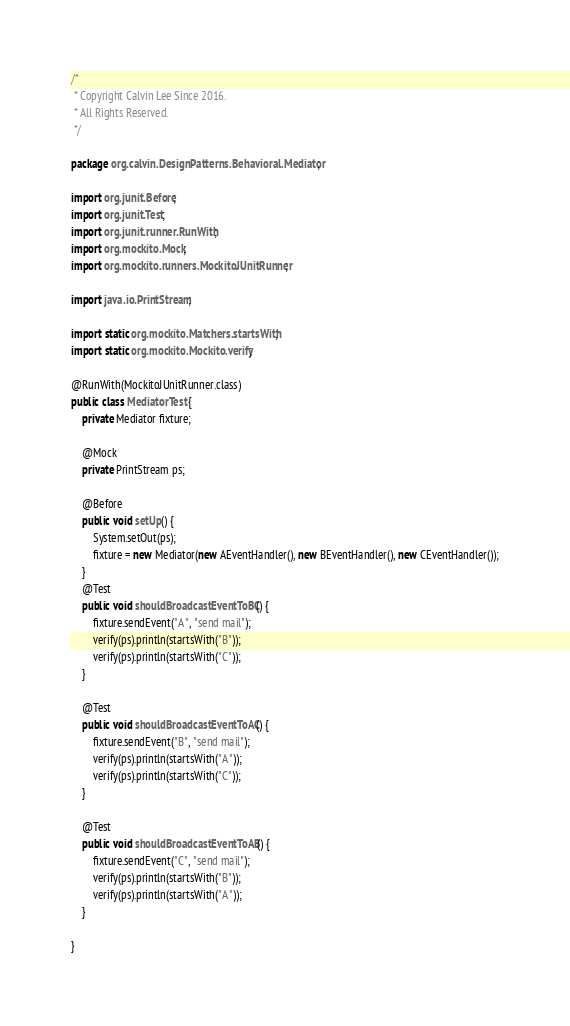Convert code to text. <code><loc_0><loc_0><loc_500><loc_500><_Java_>/*
 * Copyright Calvin Lee Since 2016.
 * All Rights Reserved.
 */

package org.calvin.DesignPatterns.Behavioral.Mediator;

import org.junit.Before;
import org.junit.Test;
import org.junit.runner.RunWith;
import org.mockito.Mock;
import org.mockito.runners.MockitoJUnitRunner;

import java.io.PrintStream;

import static org.mockito.Matchers.startsWith;
import static org.mockito.Mockito.verify;

@RunWith(MockitoJUnitRunner.class)
public class MediatorTest {
    private Mediator fixture;

    @Mock
    private PrintStream ps;

    @Before
    public void setUp() {
        System.setOut(ps);
        fixture = new Mediator(new AEventHandler(), new BEventHandler(), new CEventHandler());
    }
    @Test
    public void shouldBroadcastEventToBC() {
        fixture.sendEvent("A", "send mail");
        verify(ps).println(startsWith("B"));
        verify(ps).println(startsWith("C"));
    }

    @Test
    public void shouldBroadcastEventToAC() {
        fixture.sendEvent("B", "send mail");
        verify(ps).println(startsWith("A"));
        verify(ps).println(startsWith("C"));
    }

    @Test
    public void shouldBroadcastEventToAB() {
        fixture.sendEvent("C", "send mail");
        verify(ps).println(startsWith("B"));
        verify(ps).println(startsWith("A"));
    }

}
</code> 